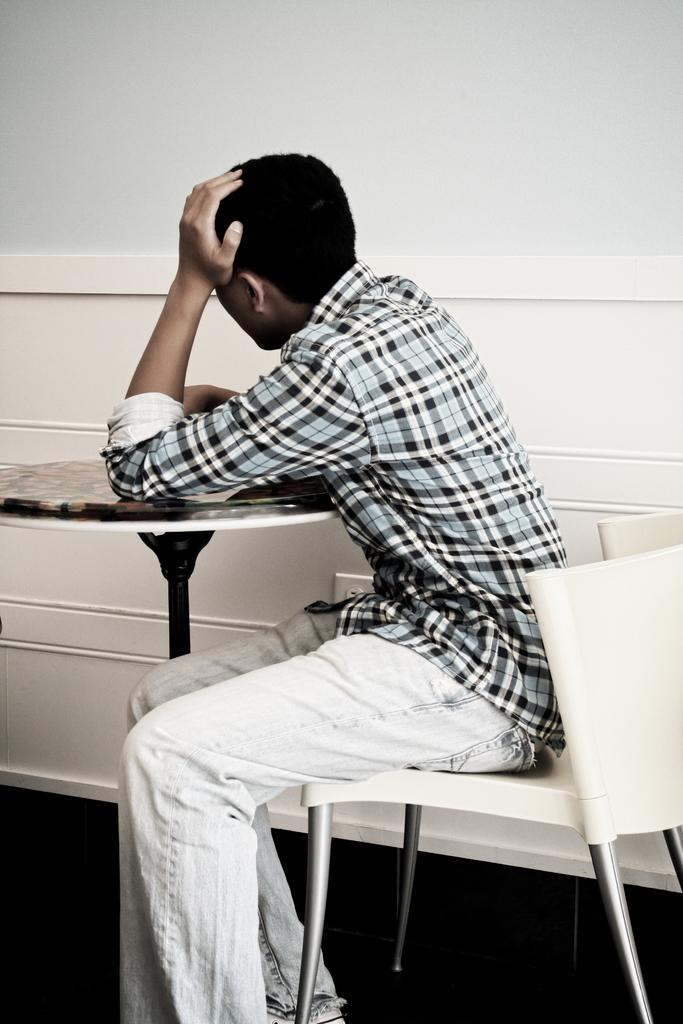Who is present in the image? There is a man in the image. What is the man wearing? The man is wearing a checked shirt. What is the man doing in the image? The man is sitting on a chair. Where is the chair located in relation to the table? The chair is in front of a table. What can be seen beneath the man's feet in the image? There is a floor visible in the image. What is visible behind the man in the image? There is a wall visible in the image. How many bears can be seen in the image? There are no bears present in the image. What type of airport is visible in the image? There is no airport visible in the image. 